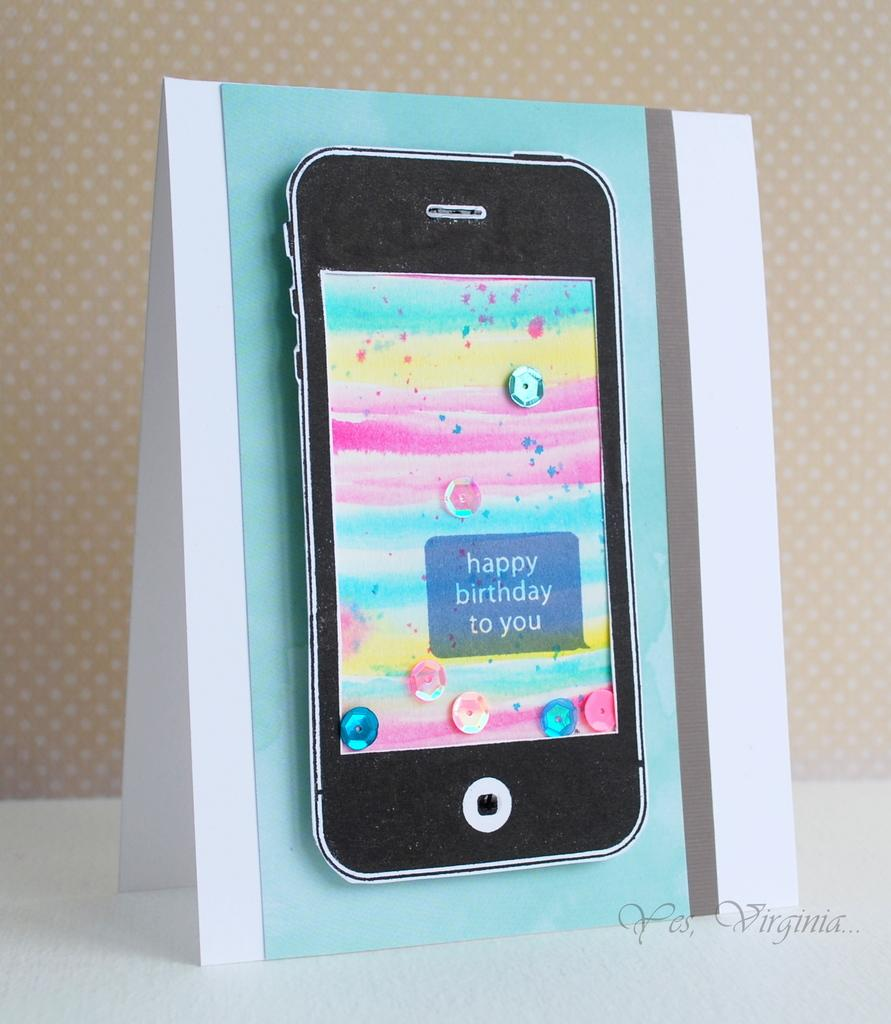Provide a one-sentence caption for the provided image. A happy birthday to you card has a picture of a phone on the front. 